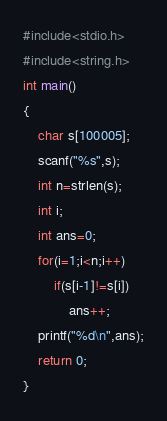Convert code to text. <code><loc_0><loc_0><loc_500><loc_500><_C_>#include<stdio.h>
#include<string.h>
int main()
{
	char s[100005];
	scanf("%s",s);
	int n=strlen(s);
	int i;
	int ans=0;
	for(i=1;i<n;i++)
	    if(s[i-1]!=s[i])
	        ans++;
	printf("%d\n",ans);
	return 0;
}</code> 